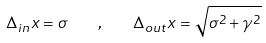Convert formula to latex. <formula><loc_0><loc_0><loc_500><loc_500>\Delta _ { i n } x = \sigma \quad , \quad \Delta _ { o u t } x = \sqrt { \sigma ^ { 2 } + \gamma ^ { 2 } }</formula> 